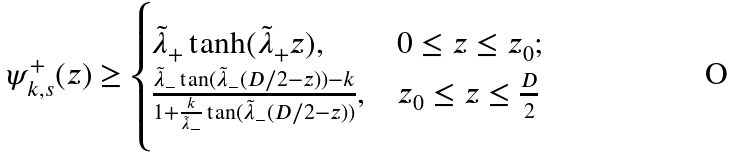<formula> <loc_0><loc_0><loc_500><loc_500>\psi ^ { + } _ { k , s } ( z ) \geq \begin{cases} \tilde { \lambda } _ { + } \tanh ( \tilde { \lambda } _ { + } z ) , & 0 \leq z \leq z _ { 0 } ; \\ \frac { \tilde { \lambda } _ { - } \tan ( \tilde { \lambda } _ { - } ( D / 2 - z ) ) - k } { 1 + \frac { k } { \tilde { \lambda } _ { - } } \tan ( \tilde { \lambda } _ { - } ( D / 2 - z ) ) } , & z _ { 0 } \leq z \leq \frac { D } { 2 } \end{cases}</formula> 